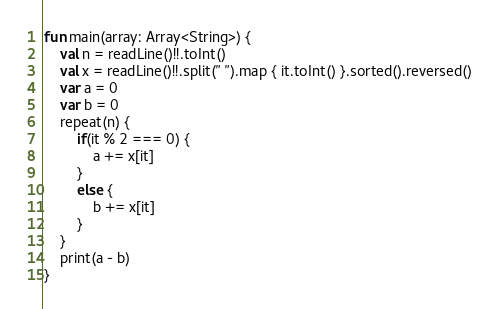Convert code to text. <code><loc_0><loc_0><loc_500><loc_500><_Kotlin_>fun main(array: Array<String>) {
    val n = readLine()!!.toInt()
    val x = readLine()!!.split(" ").map { it.toInt() }.sorted().reversed()
    var a = 0
    var b = 0
    repeat(n) {
        if(it % 2 === 0) {
            a += x[it]
        }
        else {
            b += x[it]
        }
    }
    print(a - b)
}</code> 